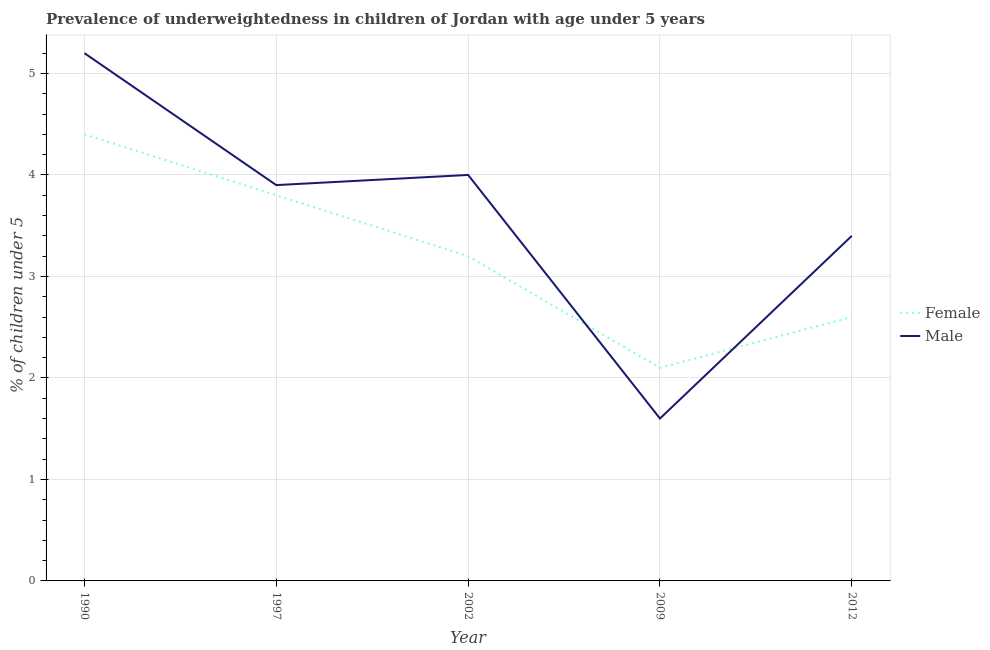How many different coloured lines are there?
Keep it short and to the point. 2. Does the line corresponding to percentage of underweighted female children intersect with the line corresponding to percentage of underweighted male children?
Offer a terse response. Yes. What is the percentage of underweighted female children in 1997?
Offer a very short reply. 3.8. Across all years, what is the maximum percentage of underweighted male children?
Ensure brevity in your answer.  5.2. Across all years, what is the minimum percentage of underweighted male children?
Make the answer very short. 1.6. What is the total percentage of underweighted male children in the graph?
Provide a succinct answer. 18.1. What is the difference between the percentage of underweighted male children in 2009 and that in 2012?
Provide a succinct answer. -1.8. What is the difference between the percentage of underweighted male children in 1997 and the percentage of underweighted female children in 2002?
Offer a terse response. 0.7. What is the average percentage of underweighted male children per year?
Make the answer very short. 3.62. In the year 1990, what is the difference between the percentage of underweighted male children and percentage of underweighted female children?
Provide a short and direct response. 0.8. In how many years, is the percentage of underweighted male children greater than 0.4 %?
Provide a short and direct response. 5. What is the ratio of the percentage of underweighted male children in 1997 to that in 2002?
Ensure brevity in your answer.  0.98. Is the percentage of underweighted male children in 1990 less than that in 2009?
Your answer should be very brief. No. Is the difference between the percentage of underweighted female children in 1997 and 2002 greater than the difference between the percentage of underweighted male children in 1997 and 2002?
Your answer should be very brief. Yes. What is the difference between the highest and the second highest percentage of underweighted female children?
Provide a short and direct response. 0.6. What is the difference between the highest and the lowest percentage of underweighted male children?
Offer a terse response. 3.6. In how many years, is the percentage of underweighted male children greater than the average percentage of underweighted male children taken over all years?
Give a very brief answer. 3. Is the sum of the percentage of underweighted male children in 1997 and 2002 greater than the maximum percentage of underweighted female children across all years?
Provide a short and direct response. Yes. Is the percentage of underweighted male children strictly greater than the percentage of underweighted female children over the years?
Ensure brevity in your answer.  No. How many lines are there?
Make the answer very short. 2. How many years are there in the graph?
Your answer should be compact. 5. What is the difference between two consecutive major ticks on the Y-axis?
Make the answer very short. 1. Are the values on the major ticks of Y-axis written in scientific E-notation?
Provide a succinct answer. No. How are the legend labels stacked?
Give a very brief answer. Vertical. What is the title of the graph?
Your response must be concise. Prevalence of underweightedness in children of Jordan with age under 5 years. Does "GDP" appear as one of the legend labels in the graph?
Offer a very short reply. No. What is the label or title of the Y-axis?
Make the answer very short.  % of children under 5. What is the  % of children under 5 of Female in 1990?
Your answer should be very brief. 4.4. What is the  % of children under 5 of Male in 1990?
Ensure brevity in your answer.  5.2. What is the  % of children under 5 of Female in 1997?
Offer a very short reply. 3.8. What is the  % of children under 5 of Male in 1997?
Keep it short and to the point. 3.9. What is the  % of children under 5 of Female in 2002?
Make the answer very short. 3.2. What is the  % of children under 5 in Male in 2002?
Offer a very short reply. 4. What is the  % of children under 5 in Female in 2009?
Provide a short and direct response. 2.1. What is the  % of children under 5 in Male in 2009?
Your answer should be compact. 1.6. What is the  % of children under 5 of Female in 2012?
Your answer should be very brief. 2.6. What is the  % of children under 5 in Male in 2012?
Provide a succinct answer. 3.4. Across all years, what is the maximum  % of children under 5 in Female?
Your answer should be compact. 4.4. Across all years, what is the maximum  % of children under 5 of Male?
Provide a succinct answer. 5.2. Across all years, what is the minimum  % of children under 5 in Female?
Keep it short and to the point. 2.1. Across all years, what is the minimum  % of children under 5 of Male?
Give a very brief answer. 1.6. What is the total  % of children under 5 in Female in the graph?
Ensure brevity in your answer.  16.1. What is the difference between the  % of children under 5 in Female in 1990 and that in 1997?
Your answer should be compact. 0.6. What is the difference between the  % of children under 5 in Male in 1990 and that in 1997?
Provide a succinct answer. 1.3. What is the difference between the  % of children under 5 in Female in 1990 and that in 2002?
Provide a short and direct response. 1.2. What is the difference between the  % of children under 5 in Male in 1990 and that in 2002?
Your response must be concise. 1.2. What is the difference between the  % of children under 5 of Female in 1990 and that in 2009?
Your response must be concise. 2.3. What is the difference between the  % of children under 5 in Female in 1990 and that in 2012?
Offer a terse response. 1.8. What is the difference between the  % of children under 5 in Male in 1990 and that in 2012?
Your response must be concise. 1.8. What is the difference between the  % of children under 5 of Female in 1997 and that in 2002?
Offer a terse response. 0.6. What is the difference between the  % of children under 5 in Male in 1997 and that in 2012?
Provide a succinct answer. 0.5. What is the difference between the  % of children under 5 in Male in 2002 and that in 2009?
Keep it short and to the point. 2.4. What is the difference between the  % of children under 5 of Male in 2002 and that in 2012?
Ensure brevity in your answer.  0.6. What is the difference between the  % of children under 5 of Male in 2009 and that in 2012?
Give a very brief answer. -1.8. What is the difference between the  % of children under 5 of Female in 1990 and the  % of children under 5 of Male in 2002?
Your answer should be compact. 0.4. What is the difference between the  % of children under 5 of Female in 1990 and the  % of children under 5 of Male in 2009?
Offer a very short reply. 2.8. What is the difference between the  % of children under 5 in Female in 1990 and the  % of children under 5 in Male in 2012?
Keep it short and to the point. 1. What is the difference between the  % of children under 5 in Female in 2009 and the  % of children under 5 in Male in 2012?
Ensure brevity in your answer.  -1.3. What is the average  % of children under 5 of Female per year?
Provide a short and direct response. 3.22. What is the average  % of children under 5 of Male per year?
Your response must be concise. 3.62. In the year 1997, what is the difference between the  % of children under 5 of Female and  % of children under 5 of Male?
Provide a succinct answer. -0.1. In the year 2009, what is the difference between the  % of children under 5 in Female and  % of children under 5 in Male?
Provide a short and direct response. 0.5. What is the ratio of the  % of children under 5 of Female in 1990 to that in 1997?
Keep it short and to the point. 1.16. What is the ratio of the  % of children under 5 of Male in 1990 to that in 1997?
Give a very brief answer. 1.33. What is the ratio of the  % of children under 5 in Female in 1990 to that in 2002?
Make the answer very short. 1.38. What is the ratio of the  % of children under 5 in Male in 1990 to that in 2002?
Offer a very short reply. 1.3. What is the ratio of the  % of children under 5 of Female in 1990 to that in 2009?
Keep it short and to the point. 2.1. What is the ratio of the  % of children under 5 in Male in 1990 to that in 2009?
Offer a very short reply. 3.25. What is the ratio of the  % of children under 5 of Female in 1990 to that in 2012?
Your answer should be very brief. 1.69. What is the ratio of the  % of children under 5 in Male in 1990 to that in 2012?
Your answer should be very brief. 1.53. What is the ratio of the  % of children under 5 in Female in 1997 to that in 2002?
Your answer should be very brief. 1.19. What is the ratio of the  % of children under 5 in Male in 1997 to that in 2002?
Make the answer very short. 0.97. What is the ratio of the  % of children under 5 of Female in 1997 to that in 2009?
Your answer should be compact. 1.81. What is the ratio of the  % of children under 5 of Male in 1997 to that in 2009?
Make the answer very short. 2.44. What is the ratio of the  % of children under 5 in Female in 1997 to that in 2012?
Make the answer very short. 1.46. What is the ratio of the  % of children under 5 of Male in 1997 to that in 2012?
Your answer should be very brief. 1.15. What is the ratio of the  % of children under 5 of Female in 2002 to that in 2009?
Give a very brief answer. 1.52. What is the ratio of the  % of children under 5 in Male in 2002 to that in 2009?
Ensure brevity in your answer.  2.5. What is the ratio of the  % of children under 5 in Female in 2002 to that in 2012?
Offer a terse response. 1.23. What is the ratio of the  % of children under 5 in Male in 2002 to that in 2012?
Your response must be concise. 1.18. What is the ratio of the  % of children under 5 of Female in 2009 to that in 2012?
Offer a terse response. 0.81. What is the ratio of the  % of children under 5 in Male in 2009 to that in 2012?
Provide a short and direct response. 0.47. What is the difference between the highest and the second highest  % of children under 5 in Male?
Offer a very short reply. 1.2. What is the difference between the highest and the lowest  % of children under 5 in Male?
Offer a very short reply. 3.6. 